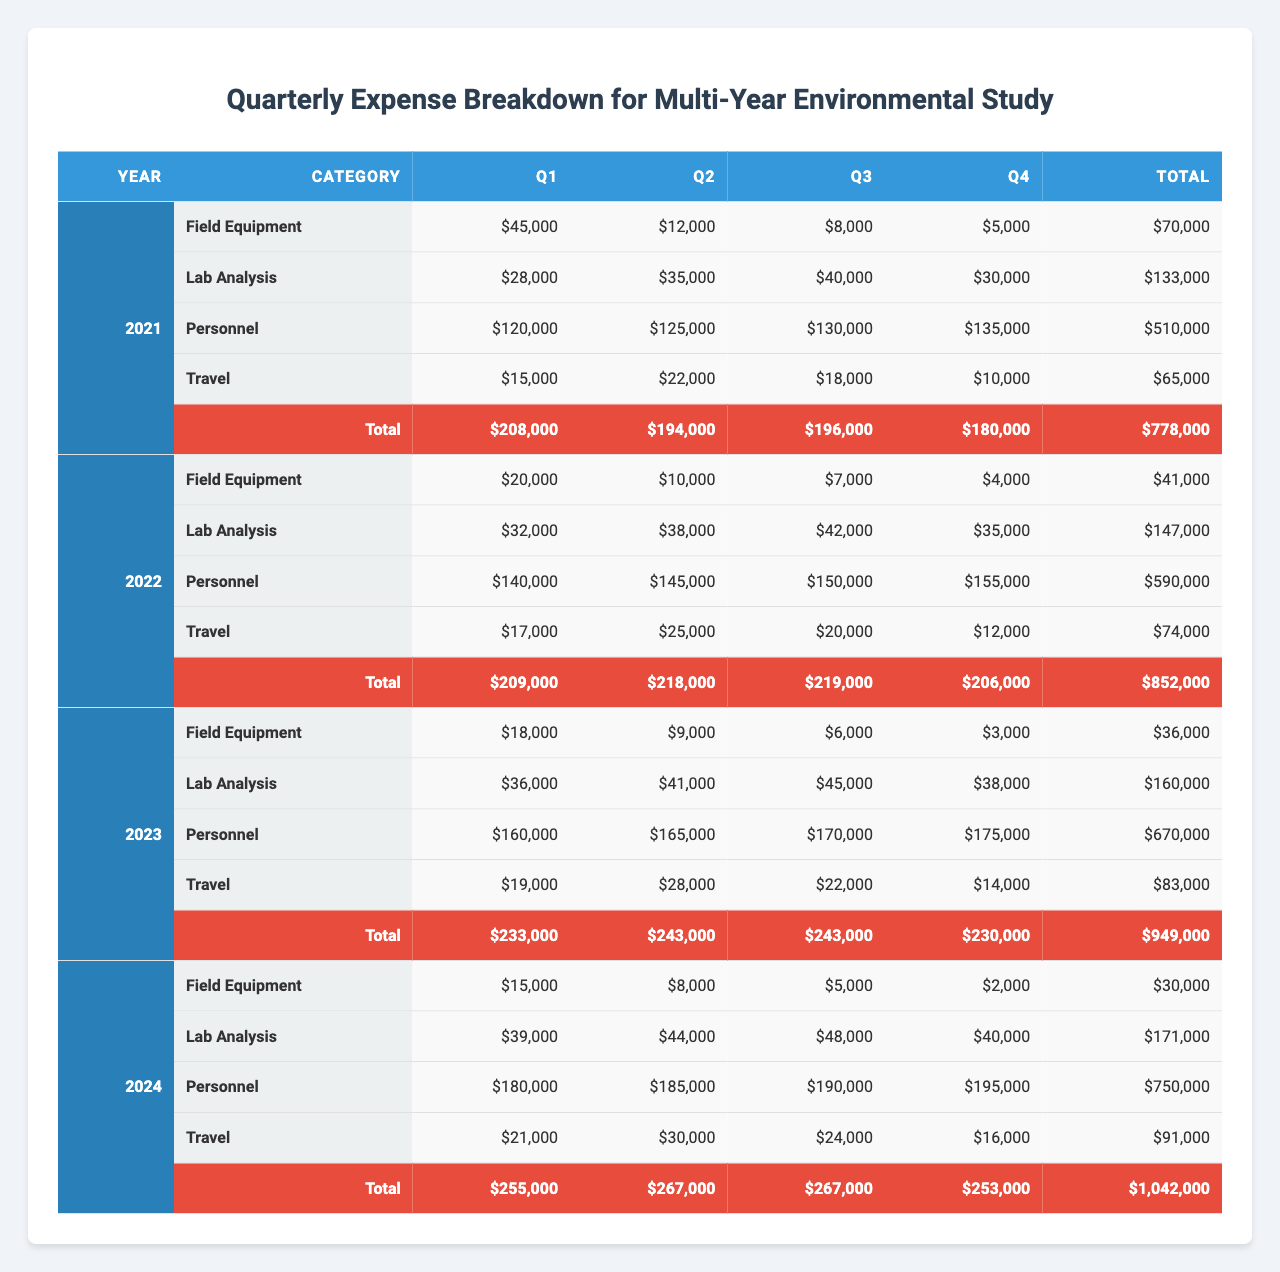What was the total expense for the year 2022? To find the total expense for 2022, add the total expenditures for each quarter: Q1: $174,000, Q2: $158,000, Q3: $155,000, Q4: $145,000. Sum these values: 174,000 + 158,000 + 155,000 + 145,000 = 632,000.
Answer: $632,000 Which quarter had the highest expense in 2023? To determine the quarter with the highest expense in 2023, compare the total expenses for each quarter: Q1: $219,000, Q2: $232,000, Q3: $228,000, Q4: $218,000. Q2 has the highest total of $232,000.
Answer: Q2 What is the average cost for 'Lab Analysis' in 2021? For 'Lab Analysis' in 2021, total the expenses for each quarter: Q1: $28,000, Q2: $35,000, Q3: $40,000, Q4: $30,000. Sum: 28,000 + 35,000 + 40,000 + 30,000 = 133,000. Divide by 4 (the number of quarters): 133,000 / 4 = $33,250.
Answer: $33,250 Is the 'Field Equipment' cost higher in 2024 compared to 2021? Compare the total costs for 'Field Equipment' in both years: In 2021, it is 45,000 + 12,000 + 8,000 + 5,000 = $70,000. In 2024, it is 15,000 + 8,000 + 5,000 + 2,000 = $30,000. $70,000 (2021) > $30,000 (2024), so the statement is true.
Answer: Yes What is the total expense for 'Travel' during the entire study period (2021-2024)? Calculate the total expenses for 'Travel' across all quarters from 2021 to 2024. For each year: 2021: 15,000 + 22,000 + 18,000 + 10,000 = 65,000; 2022: 17,000 + 25,000 + 20,000 + 12,000 = 74,000; 2023: 19,000 + 28,000 + 22,000 + 14,000 = 83,000; 2024: 21,000 + 30,000 + 24,000 + 16,000 = 91,000. Sum these totals: 65,000 + 74,000 + 83,000 + 91,000 = 313,000.
Answer: $313,000 In which year did the personnel costs first exceed $180,000? Review the personnel costs for each year: 2021: $120,000; 2022: $140,000; 2023: $160,000; 2024: $180,000. The personnel costs do not exceed $180,000 until 2024, as it's exactly $180,000 that year.
Answer: 2024 Which quarter had the lowest 'Personnel' expenses and what was the amount? Check the 'Personnel' expenses for each quarter: 2021: $120,000; 2022: $140,000; 2023: $160,000; 2024: $180,000. The lowest value is in 2021 Q1, which is $120,000.
Answer: Q1 2021, $120,000 What is the difference between the total expenses in Q4 of 2023 and Q4 of 2022? First, find the total expenses for Q4 in both years. Q4 2023: $218,000, Q4 2022: $155,000. Calculate the difference: 218,000 - 155,000 = 63,000.
Answer: $63,000 What was the average expense for 'Field Equipment' in 2021? The expenses for 'Field Equipment' in 2021 are: Q1: $45,000, Q2: $12,000, Q3: $8,000, Q4: $5,000. Total = 45,000 + 12,000 + 8,000 + 5,000 = $70,000. Divide by 4: $70,000 / 4 = $17,500.
Answer: $17,500 How much did ‘Lab Analysis’ cost in total across all quarters for 2023? Total the 'Lab Analysis' expenses for 2023: Q1: $36,000, Q2: $41,000, Q3: $45,000, Q4: $38,000. Sum these amounts: 36,000 + 41,000 + 45,000 + 38,000 = 160,000.
Answer: $160,000 Was the total expense in Q2 of 2022 lower than that in Q1 of 2023? First, calculate total expenses for Q2 2022: Q2 2022: 10,000 (Field Equipment) + 38,000 (Lab Analysis) + 145,000 (Personnel) + 25,000 (Travel) = 158,000. Q1 2023 total: 18,000 + 36,000 + 160,000 + 19,000 = 233,000. Since 158,000 < 233,000, the statement is true.
Answer: Yes 